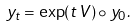<formula> <loc_0><loc_0><loc_500><loc_500>y _ { t } = \exp ( t \, V ) \circ y _ { 0 } .</formula> 